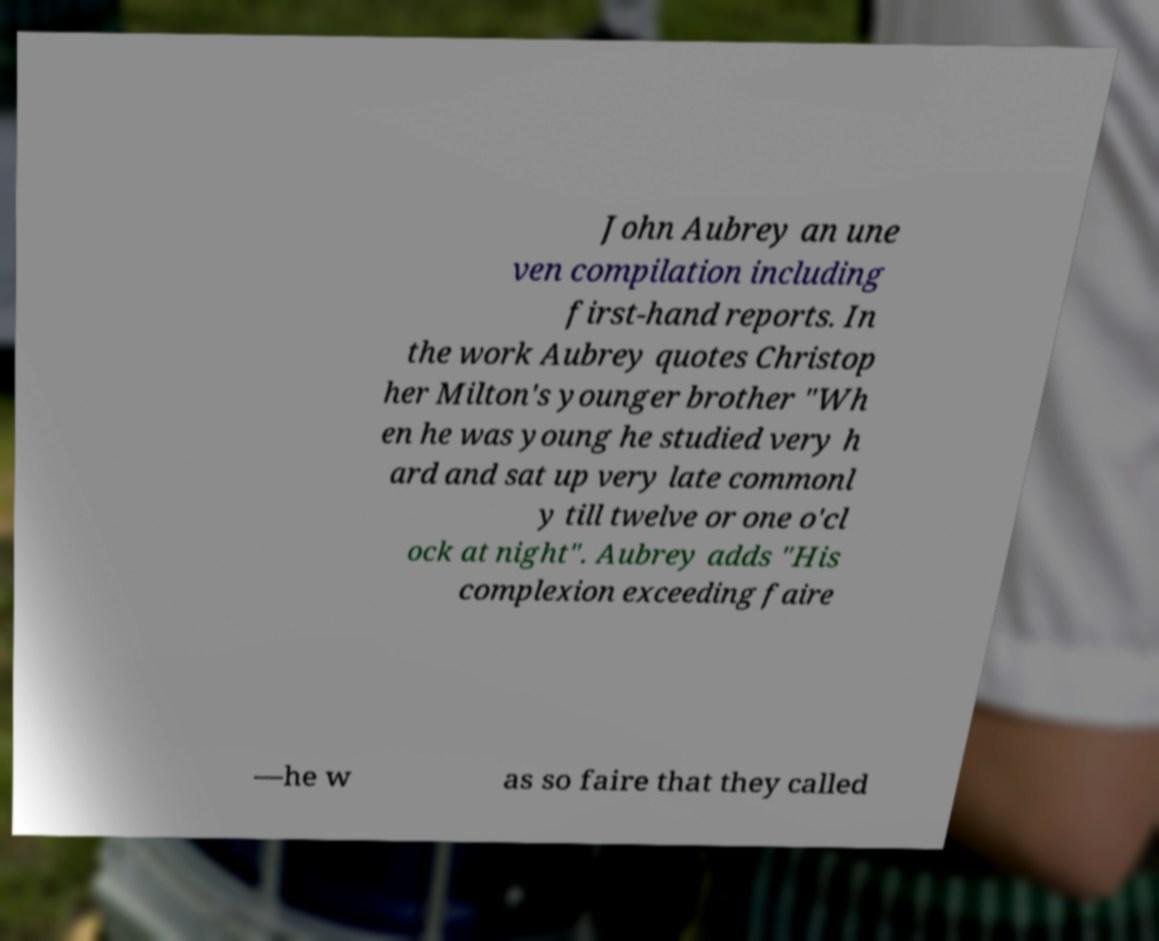Could you extract and type out the text from this image? John Aubrey an une ven compilation including first-hand reports. In the work Aubrey quotes Christop her Milton's younger brother "Wh en he was young he studied very h ard and sat up very late commonl y till twelve or one o'cl ock at night". Aubrey adds "His complexion exceeding faire —he w as so faire that they called 